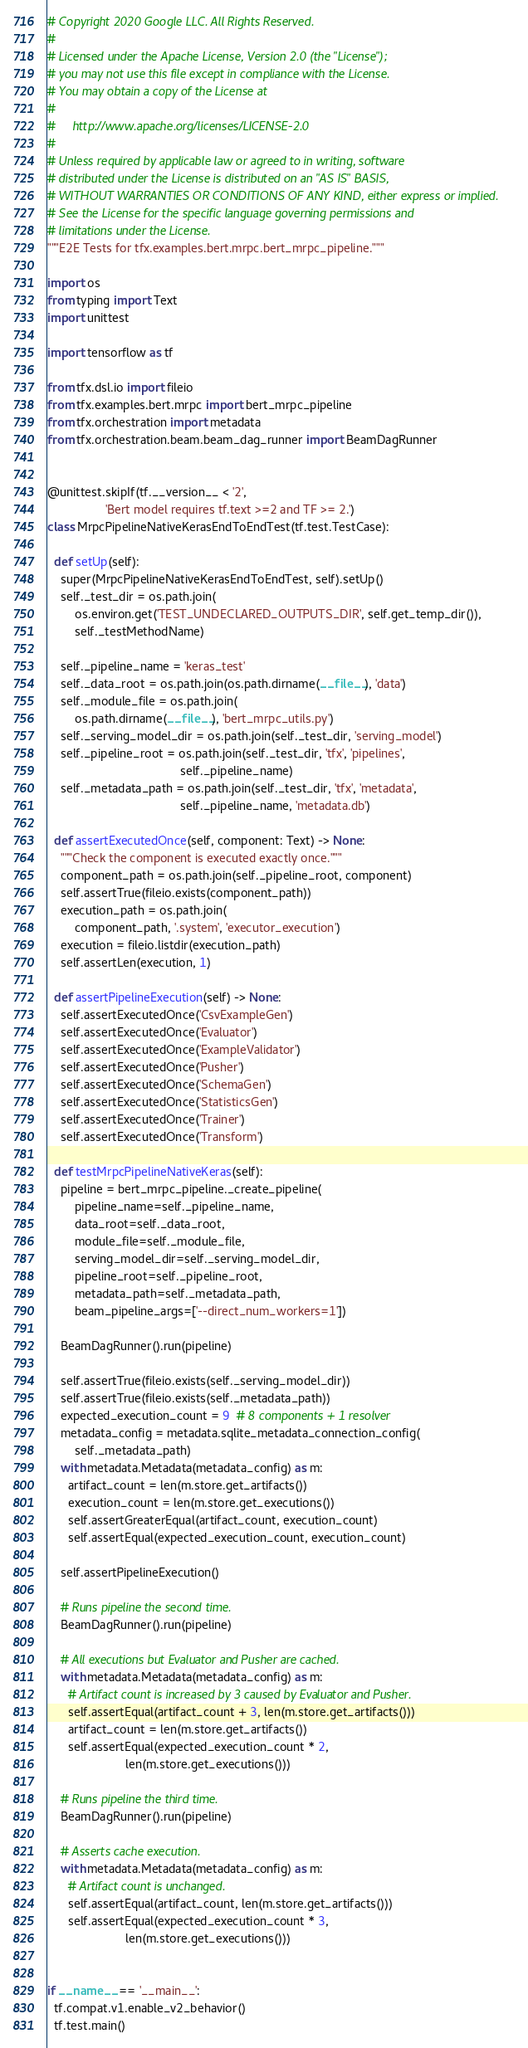Convert code to text. <code><loc_0><loc_0><loc_500><loc_500><_Python_># Copyright 2020 Google LLC. All Rights Reserved.
#
# Licensed under the Apache License, Version 2.0 (the "License");
# you may not use this file except in compliance with the License.
# You may obtain a copy of the License at
#
#     http://www.apache.org/licenses/LICENSE-2.0
#
# Unless required by applicable law or agreed to in writing, software
# distributed under the License is distributed on an "AS IS" BASIS,
# WITHOUT WARRANTIES OR CONDITIONS OF ANY KIND, either express or implied.
# See the License for the specific language governing permissions and
# limitations under the License.
"""E2E Tests for tfx.examples.bert.mrpc.bert_mrpc_pipeline."""

import os
from typing import Text
import unittest

import tensorflow as tf

from tfx.dsl.io import fileio
from tfx.examples.bert.mrpc import bert_mrpc_pipeline
from tfx.orchestration import metadata
from tfx.orchestration.beam.beam_dag_runner import BeamDagRunner


@unittest.skipIf(tf.__version__ < '2',
                 'Bert model requires tf.text >=2 and TF >= 2.')
class MrpcPipelineNativeKerasEndToEndTest(tf.test.TestCase):

  def setUp(self):
    super(MrpcPipelineNativeKerasEndToEndTest, self).setUp()
    self._test_dir = os.path.join(
        os.environ.get('TEST_UNDECLARED_OUTPUTS_DIR', self.get_temp_dir()),
        self._testMethodName)

    self._pipeline_name = 'keras_test'
    self._data_root = os.path.join(os.path.dirname(__file__), 'data')
    self._module_file = os.path.join(
        os.path.dirname(__file__), 'bert_mrpc_utils.py')
    self._serving_model_dir = os.path.join(self._test_dir, 'serving_model')
    self._pipeline_root = os.path.join(self._test_dir, 'tfx', 'pipelines',
                                       self._pipeline_name)
    self._metadata_path = os.path.join(self._test_dir, 'tfx', 'metadata',
                                       self._pipeline_name, 'metadata.db')

  def assertExecutedOnce(self, component: Text) -> None:
    """Check the component is executed exactly once."""
    component_path = os.path.join(self._pipeline_root, component)
    self.assertTrue(fileio.exists(component_path))
    execution_path = os.path.join(
        component_path, '.system', 'executor_execution')
    execution = fileio.listdir(execution_path)
    self.assertLen(execution, 1)

  def assertPipelineExecution(self) -> None:
    self.assertExecutedOnce('CsvExampleGen')
    self.assertExecutedOnce('Evaluator')
    self.assertExecutedOnce('ExampleValidator')
    self.assertExecutedOnce('Pusher')
    self.assertExecutedOnce('SchemaGen')
    self.assertExecutedOnce('StatisticsGen')
    self.assertExecutedOnce('Trainer')
    self.assertExecutedOnce('Transform')

  def testMrpcPipelineNativeKeras(self):
    pipeline = bert_mrpc_pipeline._create_pipeline(
        pipeline_name=self._pipeline_name,
        data_root=self._data_root,
        module_file=self._module_file,
        serving_model_dir=self._serving_model_dir,
        pipeline_root=self._pipeline_root,
        metadata_path=self._metadata_path,
        beam_pipeline_args=['--direct_num_workers=1'])

    BeamDagRunner().run(pipeline)

    self.assertTrue(fileio.exists(self._serving_model_dir))
    self.assertTrue(fileio.exists(self._metadata_path))
    expected_execution_count = 9  # 8 components + 1 resolver
    metadata_config = metadata.sqlite_metadata_connection_config(
        self._metadata_path)
    with metadata.Metadata(metadata_config) as m:
      artifact_count = len(m.store.get_artifacts())
      execution_count = len(m.store.get_executions())
      self.assertGreaterEqual(artifact_count, execution_count)
      self.assertEqual(expected_execution_count, execution_count)

    self.assertPipelineExecution()

    # Runs pipeline the second time.
    BeamDagRunner().run(pipeline)

    # All executions but Evaluator and Pusher are cached.
    with metadata.Metadata(metadata_config) as m:
      # Artifact count is increased by 3 caused by Evaluator and Pusher.
      self.assertEqual(artifact_count + 3, len(m.store.get_artifacts()))
      artifact_count = len(m.store.get_artifacts())
      self.assertEqual(expected_execution_count * 2,
                       len(m.store.get_executions()))

    # Runs pipeline the third time.
    BeamDagRunner().run(pipeline)

    # Asserts cache execution.
    with metadata.Metadata(metadata_config) as m:
      # Artifact count is unchanged.
      self.assertEqual(artifact_count, len(m.store.get_artifacts()))
      self.assertEqual(expected_execution_count * 3,
                       len(m.store.get_executions()))


if __name__ == '__main__':
  tf.compat.v1.enable_v2_behavior()
  tf.test.main()
</code> 